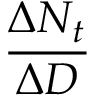<formula> <loc_0><loc_0><loc_500><loc_500>\frac { \Delta N _ { t } } { \Delta D }</formula> 